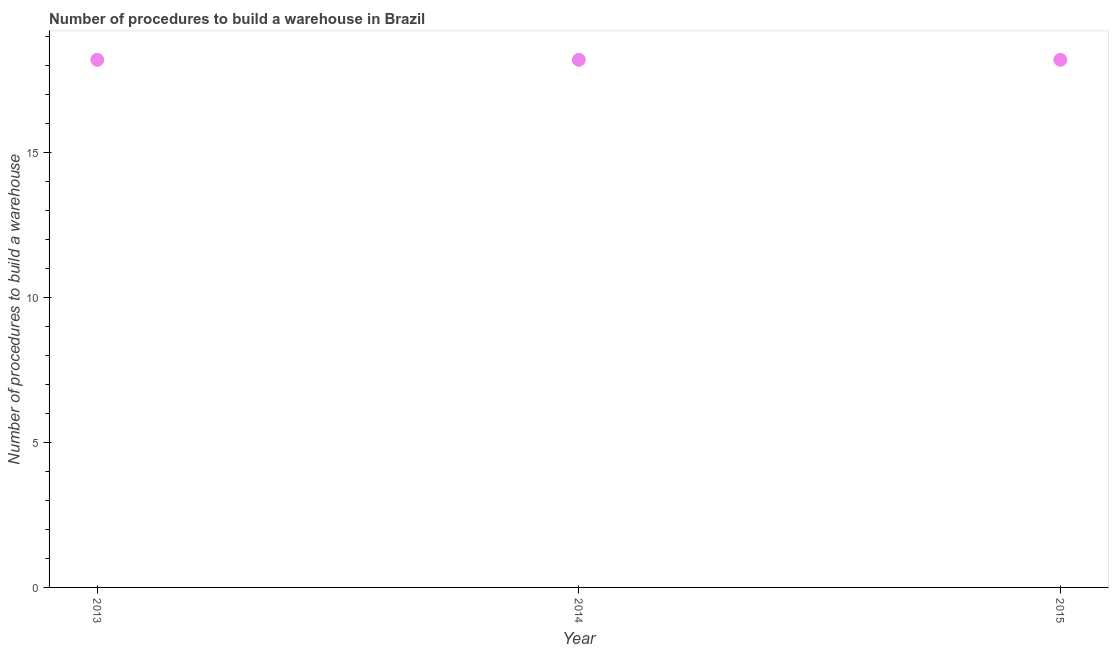Across all years, what is the maximum number of procedures to build a warehouse?
Your response must be concise. 18.2. In which year was the number of procedures to build a warehouse maximum?
Provide a succinct answer. 2013. In which year was the number of procedures to build a warehouse minimum?
Ensure brevity in your answer.  2013. What is the sum of the number of procedures to build a warehouse?
Provide a succinct answer. 54.6. What is the difference between the number of procedures to build a warehouse in 2013 and 2014?
Give a very brief answer. 0. What is the average number of procedures to build a warehouse per year?
Give a very brief answer. 18.2. What is the median number of procedures to build a warehouse?
Make the answer very short. 18.2. Do a majority of the years between 2015 and 2014 (inclusive) have number of procedures to build a warehouse greater than 15 ?
Your answer should be very brief. No. Is the number of procedures to build a warehouse in 2014 less than that in 2015?
Your answer should be compact. No. Is the difference between the number of procedures to build a warehouse in 2014 and 2015 greater than the difference between any two years?
Make the answer very short. Yes. What is the difference between the highest and the second highest number of procedures to build a warehouse?
Your answer should be compact. 0. Is the sum of the number of procedures to build a warehouse in 2014 and 2015 greater than the maximum number of procedures to build a warehouse across all years?
Offer a very short reply. Yes. In how many years, is the number of procedures to build a warehouse greater than the average number of procedures to build a warehouse taken over all years?
Your answer should be very brief. 0. Does the number of procedures to build a warehouse monotonically increase over the years?
Provide a succinct answer. No. How many dotlines are there?
Ensure brevity in your answer.  1. How many years are there in the graph?
Provide a succinct answer. 3. Are the values on the major ticks of Y-axis written in scientific E-notation?
Make the answer very short. No. Does the graph contain any zero values?
Make the answer very short. No. What is the title of the graph?
Provide a succinct answer. Number of procedures to build a warehouse in Brazil. What is the label or title of the X-axis?
Your answer should be very brief. Year. What is the label or title of the Y-axis?
Make the answer very short. Number of procedures to build a warehouse. What is the Number of procedures to build a warehouse in 2013?
Ensure brevity in your answer.  18.2. What is the difference between the Number of procedures to build a warehouse in 2013 and 2014?
Your answer should be very brief. 0. What is the difference between the Number of procedures to build a warehouse in 2013 and 2015?
Your answer should be compact. 0. 